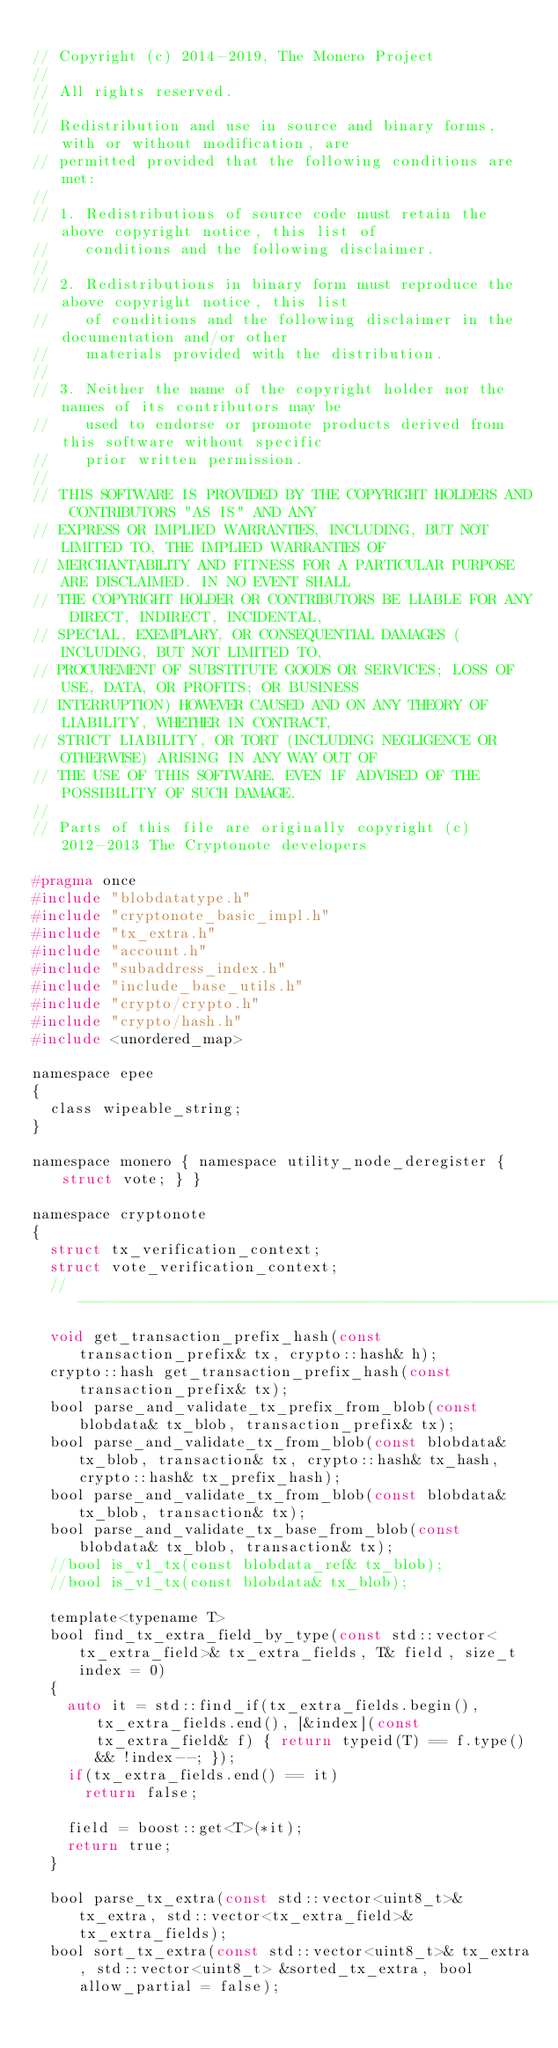Convert code to text. <code><loc_0><loc_0><loc_500><loc_500><_C_>
// Copyright (c) 2014-2019, The Monero Project
//
// All rights reserved.
//
// Redistribution and use in source and binary forms, with or without modification, are
// permitted provided that the following conditions are met:
//
// 1. Redistributions of source code must retain the above copyright notice, this list of
//    conditions and the following disclaimer.
//
// 2. Redistributions in binary form must reproduce the above copyright notice, this list
//    of conditions and the following disclaimer in the documentation and/or other
//    materials provided with the distribution.
//
// 3. Neither the name of the copyright holder nor the names of its contributors may be
//    used to endorse or promote products derived from this software without specific
//    prior written permission.
//
// THIS SOFTWARE IS PROVIDED BY THE COPYRIGHT HOLDERS AND CONTRIBUTORS "AS IS" AND ANY
// EXPRESS OR IMPLIED WARRANTIES, INCLUDING, BUT NOT LIMITED TO, THE IMPLIED WARRANTIES OF
// MERCHANTABILITY AND FITNESS FOR A PARTICULAR PURPOSE ARE DISCLAIMED. IN NO EVENT SHALL
// THE COPYRIGHT HOLDER OR CONTRIBUTORS BE LIABLE FOR ANY DIRECT, INDIRECT, INCIDENTAL,
// SPECIAL, EXEMPLARY, OR CONSEQUENTIAL DAMAGES (INCLUDING, BUT NOT LIMITED TO,
// PROCUREMENT OF SUBSTITUTE GOODS OR SERVICES; LOSS OF USE, DATA, OR PROFITS; OR BUSINESS
// INTERRUPTION) HOWEVER CAUSED AND ON ANY THEORY OF LIABILITY, WHETHER IN CONTRACT,
// STRICT LIABILITY, OR TORT (INCLUDING NEGLIGENCE OR OTHERWISE) ARISING IN ANY WAY OUT OF
// THE USE OF THIS SOFTWARE, EVEN IF ADVISED OF THE POSSIBILITY OF SUCH DAMAGE.
//
// Parts of this file are originally copyright (c) 2012-2013 The Cryptonote developers

#pragma once
#include "blobdatatype.h"
#include "cryptonote_basic_impl.h"
#include "tx_extra.h"
#include "account.h"
#include "subaddress_index.h"
#include "include_base_utils.h"
#include "crypto/crypto.h"
#include "crypto/hash.h"
#include <unordered_map>

namespace epee
{
  class wipeable_string;
}

namespace monero { namespace utility_node_deregister { struct vote; } }

namespace cryptonote
{
  struct tx_verification_context;
  struct vote_verification_context;
  //---------------------------------------------------------------
  void get_transaction_prefix_hash(const transaction_prefix& tx, crypto::hash& h);
  crypto::hash get_transaction_prefix_hash(const transaction_prefix& tx);
  bool parse_and_validate_tx_prefix_from_blob(const blobdata& tx_blob, transaction_prefix& tx);
  bool parse_and_validate_tx_from_blob(const blobdata& tx_blob, transaction& tx, crypto::hash& tx_hash, crypto::hash& tx_prefix_hash);
  bool parse_and_validate_tx_from_blob(const blobdata& tx_blob, transaction& tx);
  bool parse_and_validate_tx_base_from_blob(const blobdata& tx_blob, transaction& tx);
  //bool is_v1_tx(const blobdata_ref& tx_blob);
  //bool is_v1_tx(const blobdata& tx_blob);

  template<typename T>
  bool find_tx_extra_field_by_type(const std::vector<tx_extra_field>& tx_extra_fields, T& field, size_t index = 0)
  {
    auto it = std::find_if(tx_extra_fields.begin(), tx_extra_fields.end(), [&index](const tx_extra_field& f) { return typeid(T) == f.type() && !index--; });
    if(tx_extra_fields.end() == it)
      return false;

    field = boost::get<T>(*it);
    return true;
  }

  bool parse_tx_extra(const std::vector<uint8_t>& tx_extra, std::vector<tx_extra_field>& tx_extra_fields);
  bool sort_tx_extra(const std::vector<uint8_t>& tx_extra, std::vector<uint8_t> &sorted_tx_extra, bool allow_partial = false);</code> 